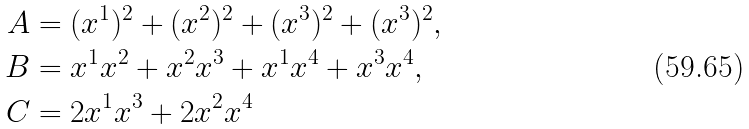Convert formula to latex. <formula><loc_0><loc_0><loc_500><loc_500>A & = ( x ^ { 1 } ) ^ { 2 } + ( x ^ { 2 } ) ^ { 2 } + ( x ^ { 3 } ) ^ { 2 } + ( x ^ { 3 } ) ^ { 2 } , \\ B & = x ^ { 1 } x ^ { 2 } + x ^ { 2 } x ^ { 3 } + x ^ { 1 } x ^ { 4 } + x ^ { 3 } x ^ { 4 } , \\ C & = 2 x ^ { 1 } x ^ { 3 } + 2 x ^ { 2 } x ^ { 4 }</formula> 